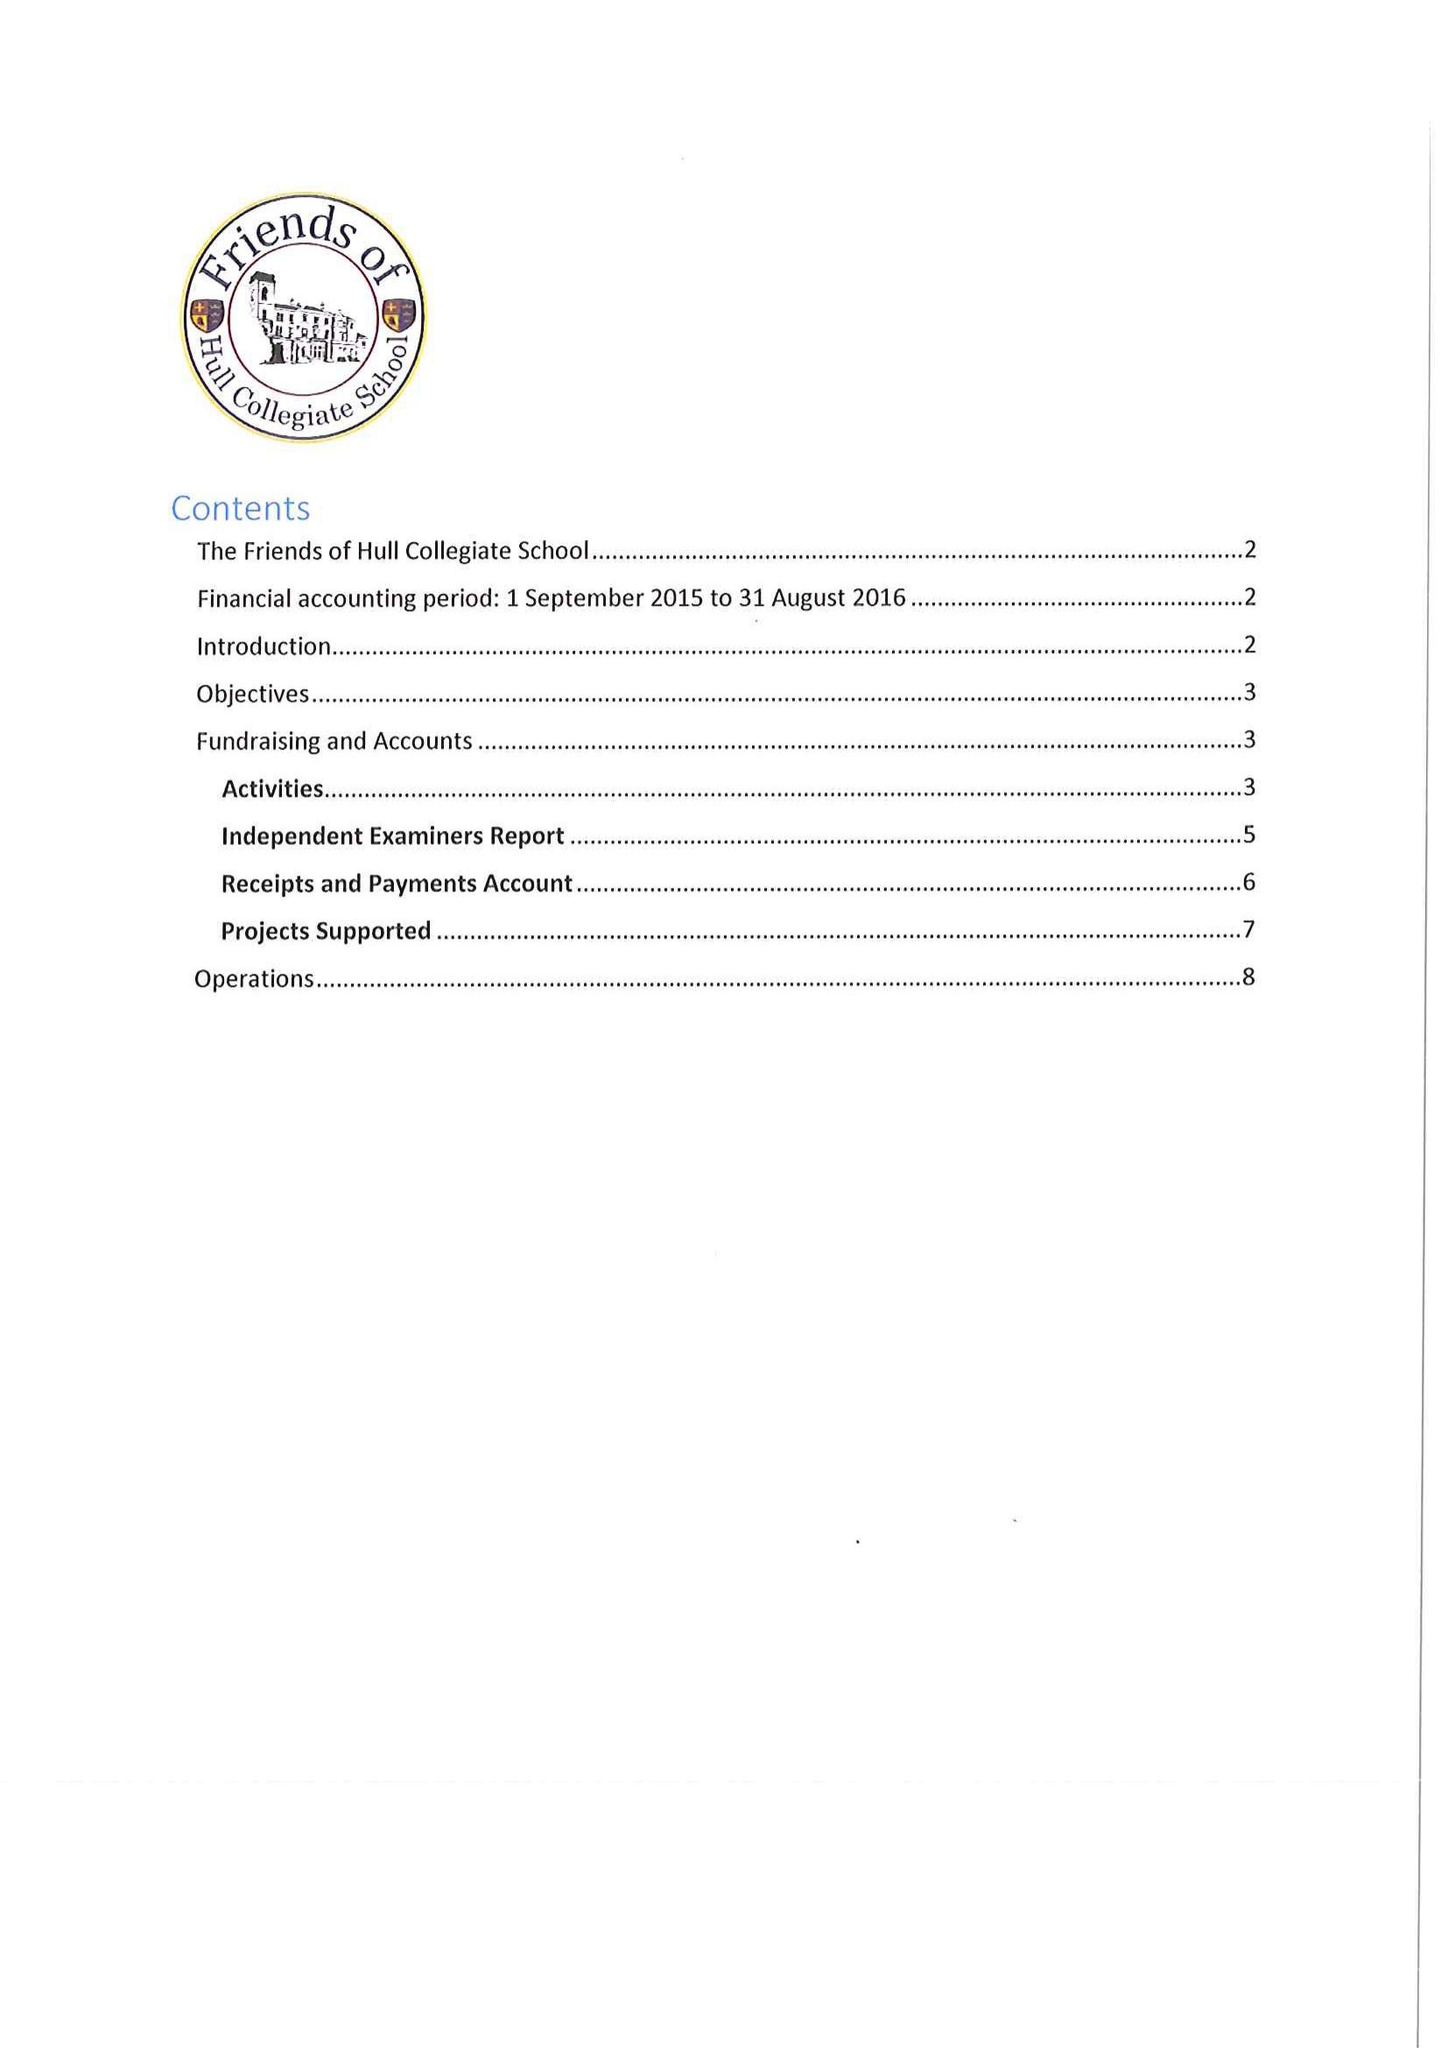What is the value for the income_annually_in_british_pounds?
Answer the question using a single word or phrase. 26912.00 